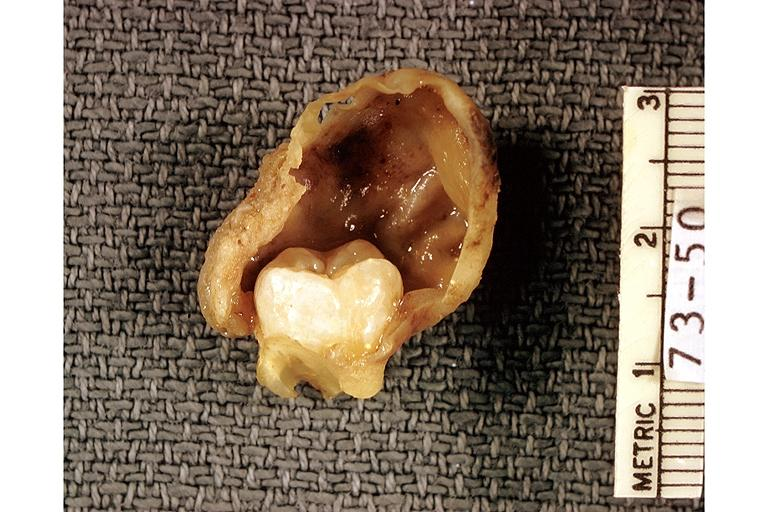what does this image show?
Answer the question using a single word or phrase. Dentigerous cyst 